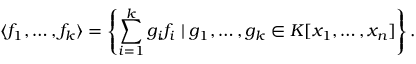<formula> <loc_0><loc_0><loc_500><loc_500>\langle f _ { 1 } , \dots , f _ { k } \rangle = \left \{ \sum _ { i = 1 } ^ { k } g _ { i } f _ { i } \, | \, g _ { 1 } , \dots , g _ { k } \in K [ x _ { 1 } , \dots , x _ { n } ] \right \} .</formula> 